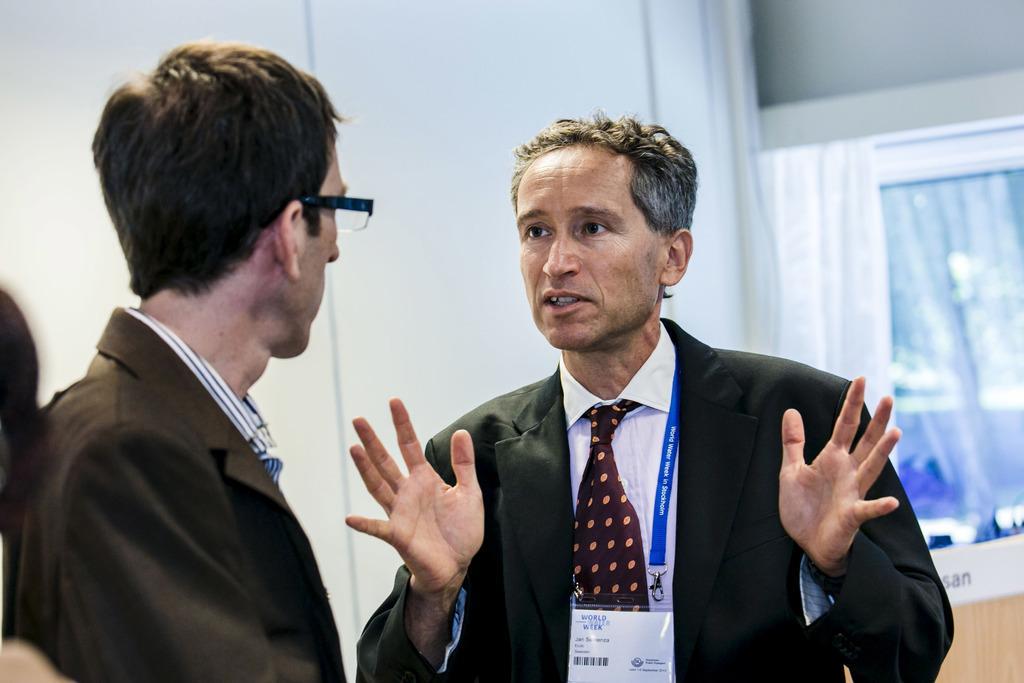Please provide a concise description of this image. In this image, the person standing on the right side, is wearing id card and on the left, there is an another person standing. In the background, there is a wall. 